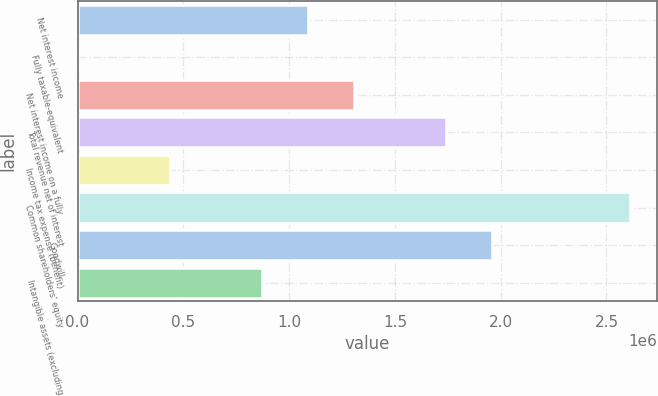Convert chart. <chart><loc_0><loc_0><loc_500><loc_500><bar_chart><fcel>Net interest income<fcel>Fully taxable-equivalent<fcel>Net interest income on a fully<fcel>Total revenue net of interest<fcel>Income tax expense (benefit)<fcel>Common shareholders' equity<fcel>Goodwill<fcel>Intangible assets (excluding<nl><fcel>1.08752e+06<fcel>211<fcel>1.30498e+06<fcel>1.7399e+06<fcel>435133<fcel>2.60974e+06<fcel>1.95736e+06<fcel>870054<nl></chart> 